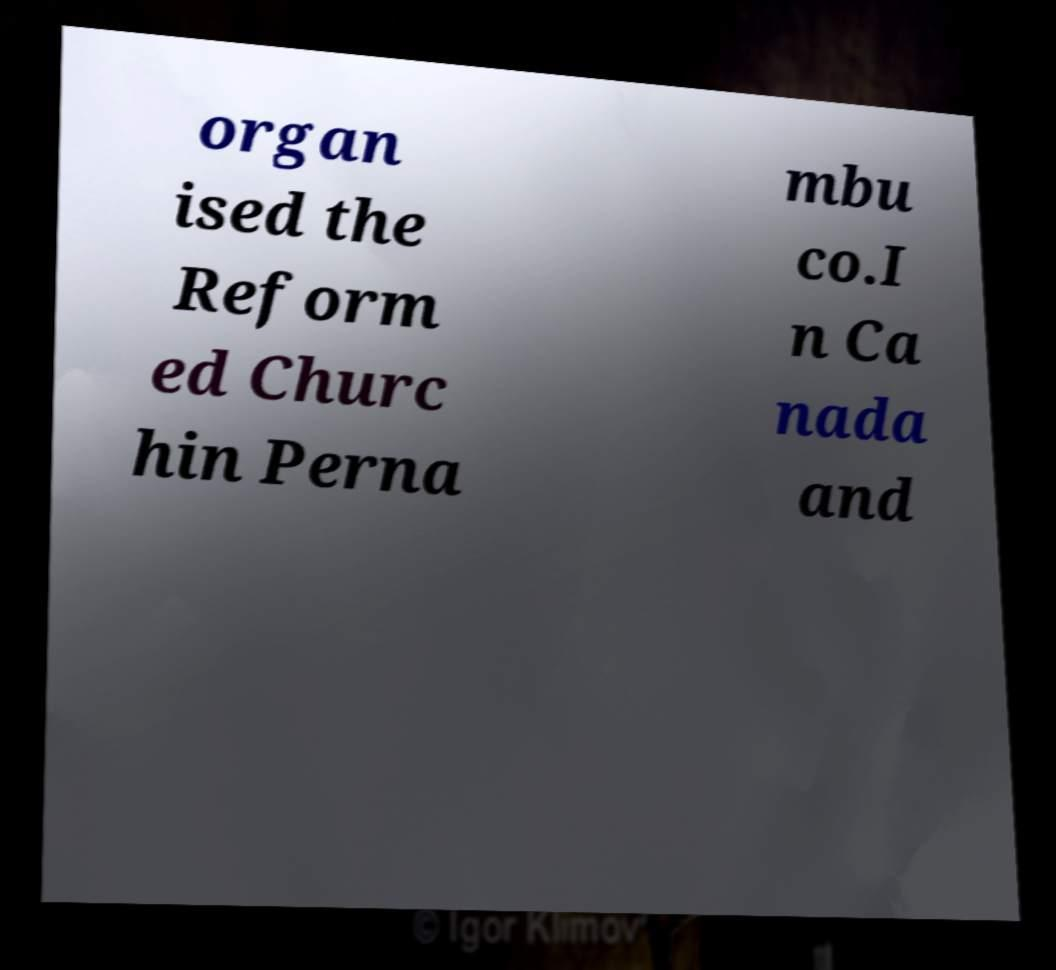I need the written content from this picture converted into text. Can you do that? organ ised the Reform ed Churc hin Perna mbu co.I n Ca nada and 